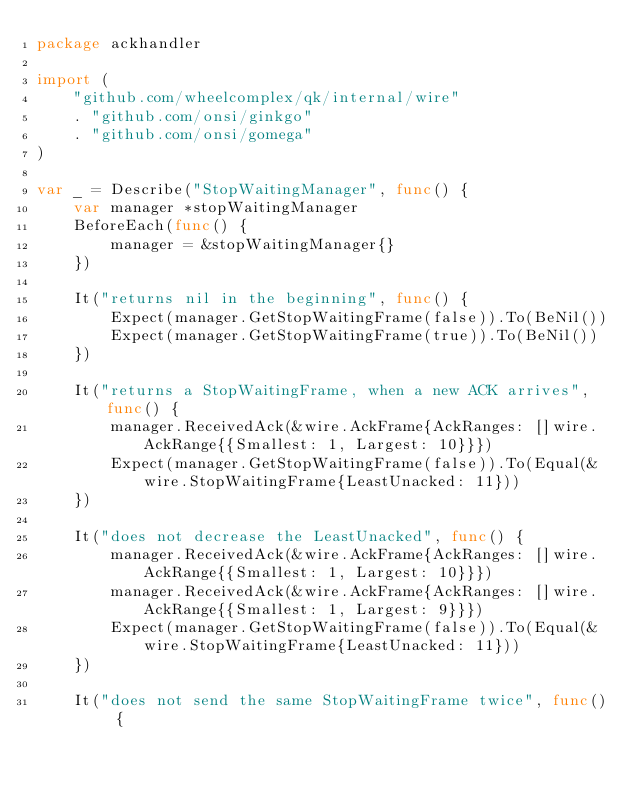<code> <loc_0><loc_0><loc_500><loc_500><_Go_>package ackhandler

import (
	"github.com/wheelcomplex/qk/internal/wire"
	. "github.com/onsi/ginkgo"
	. "github.com/onsi/gomega"
)

var _ = Describe("StopWaitingManager", func() {
	var manager *stopWaitingManager
	BeforeEach(func() {
		manager = &stopWaitingManager{}
	})

	It("returns nil in the beginning", func() {
		Expect(manager.GetStopWaitingFrame(false)).To(BeNil())
		Expect(manager.GetStopWaitingFrame(true)).To(BeNil())
	})

	It("returns a StopWaitingFrame, when a new ACK arrives", func() {
		manager.ReceivedAck(&wire.AckFrame{AckRanges: []wire.AckRange{{Smallest: 1, Largest: 10}}})
		Expect(manager.GetStopWaitingFrame(false)).To(Equal(&wire.StopWaitingFrame{LeastUnacked: 11}))
	})

	It("does not decrease the LeastUnacked", func() {
		manager.ReceivedAck(&wire.AckFrame{AckRanges: []wire.AckRange{{Smallest: 1, Largest: 10}}})
		manager.ReceivedAck(&wire.AckFrame{AckRanges: []wire.AckRange{{Smallest: 1, Largest: 9}}})
		Expect(manager.GetStopWaitingFrame(false)).To(Equal(&wire.StopWaitingFrame{LeastUnacked: 11}))
	})

	It("does not send the same StopWaitingFrame twice", func() {</code> 